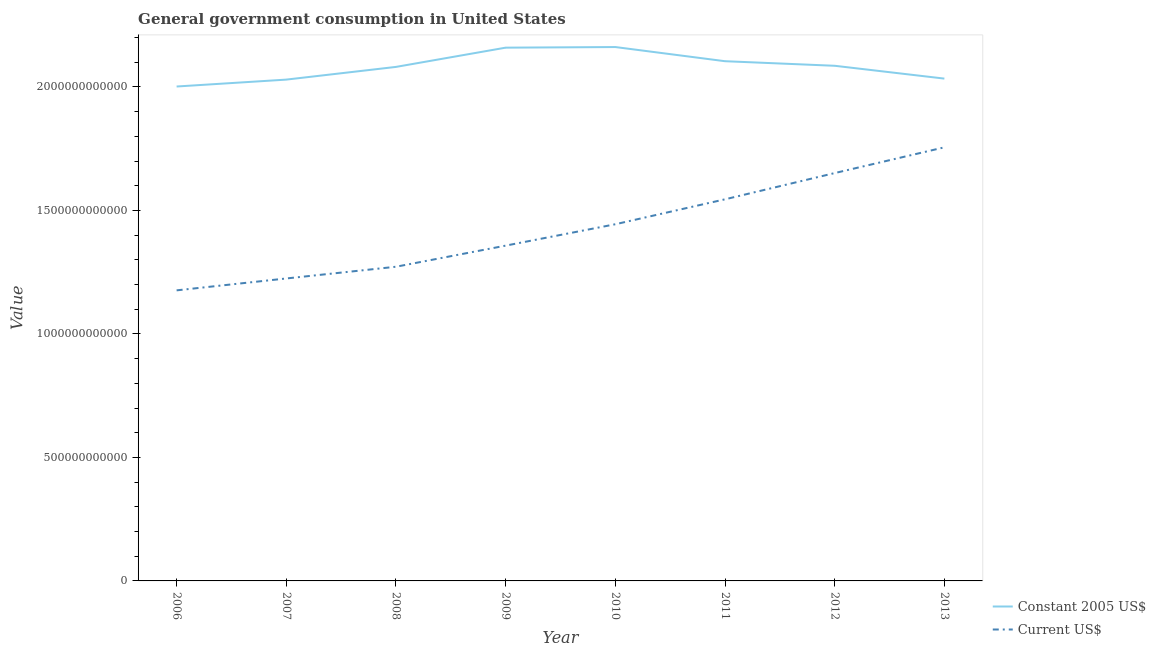What is the value consumed in constant 2005 us$ in 2007?
Make the answer very short. 2.03e+12. Across all years, what is the maximum value consumed in constant 2005 us$?
Your answer should be very brief. 2.16e+12. Across all years, what is the minimum value consumed in constant 2005 us$?
Give a very brief answer. 2.00e+12. In which year was the value consumed in current us$ maximum?
Provide a succinct answer. 2013. In which year was the value consumed in constant 2005 us$ minimum?
Ensure brevity in your answer.  2006. What is the total value consumed in constant 2005 us$ in the graph?
Offer a terse response. 1.67e+13. What is the difference between the value consumed in current us$ in 2008 and that in 2009?
Offer a very short reply. -8.55e+1. What is the difference between the value consumed in constant 2005 us$ in 2013 and the value consumed in current us$ in 2011?
Keep it short and to the point. 4.89e+11. What is the average value consumed in constant 2005 us$ per year?
Offer a terse response. 2.08e+12. In the year 2007, what is the difference between the value consumed in current us$ and value consumed in constant 2005 us$?
Provide a short and direct response. -8.05e+11. What is the ratio of the value consumed in current us$ in 2009 to that in 2010?
Your answer should be very brief. 0.94. Is the value consumed in constant 2005 us$ in 2009 less than that in 2010?
Offer a terse response. Yes. What is the difference between the highest and the second highest value consumed in current us$?
Keep it short and to the point. 1.04e+11. What is the difference between the highest and the lowest value consumed in current us$?
Your response must be concise. 5.79e+11. Does the value consumed in constant 2005 us$ monotonically increase over the years?
Your response must be concise. No. Is the value consumed in constant 2005 us$ strictly greater than the value consumed in current us$ over the years?
Offer a very short reply. Yes. How many lines are there?
Provide a short and direct response. 2. How many years are there in the graph?
Offer a terse response. 8. What is the difference between two consecutive major ticks on the Y-axis?
Offer a very short reply. 5.00e+11. Where does the legend appear in the graph?
Your answer should be very brief. Bottom right. How many legend labels are there?
Provide a succinct answer. 2. What is the title of the graph?
Offer a very short reply. General government consumption in United States. Does "Investments" appear as one of the legend labels in the graph?
Provide a short and direct response. No. What is the label or title of the X-axis?
Give a very brief answer. Year. What is the label or title of the Y-axis?
Provide a short and direct response. Value. What is the Value of Constant 2005 US$ in 2006?
Offer a very short reply. 2.00e+12. What is the Value of Current US$ in 2006?
Provide a succinct answer. 1.18e+12. What is the Value in Constant 2005 US$ in 2007?
Your answer should be very brief. 2.03e+12. What is the Value in Current US$ in 2007?
Give a very brief answer. 1.22e+12. What is the Value of Constant 2005 US$ in 2008?
Ensure brevity in your answer.  2.08e+12. What is the Value in Current US$ in 2008?
Provide a succinct answer. 1.27e+12. What is the Value of Constant 2005 US$ in 2009?
Your answer should be compact. 2.16e+12. What is the Value of Current US$ in 2009?
Your response must be concise. 1.36e+12. What is the Value of Constant 2005 US$ in 2010?
Your answer should be very brief. 2.16e+12. What is the Value in Current US$ in 2010?
Your response must be concise. 1.44e+12. What is the Value in Constant 2005 US$ in 2011?
Offer a very short reply. 2.10e+12. What is the Value of Current US$ in 2011?
Provide a short and direct response. 1.55e+12. What is the Value of Constant 2005 US$ in 2012?
Your response must be concise. 2.09e+12. What is the Value in Current US$ in 2012?
Make the answer very short. 1.65e+12. What is the Value of Constant 2005 US$ in 2013?
Ensure brevity in your answer.  2.03e+12. What is the Value in Current US$ in 2013?
Keep it short and to the point. 1.76e+12. Across all years, what is the maximum Value of Constant 2005 US$?
Provide a succinct answer. 2.16e+12. Across all years, what is the maximum Value of Current US$?
Your answer should be compact. 1.76e+12. Across all years, what is the minimum Value in Constant 2005 US$?
Give a very brief answer. 2.00e+12. Across all years, what is the minimum Value of Current US$?
Offer a very short reply. 1.18e+12. What is the total Value of Constant 2005 US$ in the graph?
Give a very brief answer. 1.67e+13. What is the total Value of Current US$ in the graph?
Your answer should be compact. 1.14e+13. What is the difference between the Value of Constant 2005 US$ in 2006 and that in 2007?
Offer a very short reply. -2.79e+1. What is the difference between the Value in Current US$ in 2006 and that in 2007?
Your answer should be compact. -4.81e+1. What is the difference between the Value of Constant 2005 US$ in 2006 and that in 2008?
Provide a succinct answer. -7.94e+1. What is the difference between the Value of Current US$ in 2006 and that in 2008?
Your answer should be very brief. -9.56e+1. What is the difference between the Value in Constant 2005 US$ in 2006 and that in 2009?
Offer a terse response. -1.57e+11. What is the difference between the Value of Current US$ in 2006 and that in 2009?
Your response must be concise. -1.81e+11. What is the difference between the Value in Constant 2005 US$ in 2006 and that in 2010?
Make the answer very short. -1.60e+11. What is the difference between the Value in Current US$ in 2006 and that in 2010?
Offer a terse response. -2.68e+11. What is the difference between the Value in Constant 2005 US$ in 2006 and that in 2011?
Your answer should be very brief. -1.02e+11. What is the difference between the Value in Current US$ in 2006 and that in 2011?
Your answer should be very brief. -3.69e+11. What is the difference between the Value in Constant 2005 US$ in 2006 and that in 2012?
Keep it short and to the point. -8.39e+1. What is the difference between the Value in Current US$ in 2006 and that in 2012?
Ensure brevity in your answer.  -4.75e+11. What is the difference between the Value in Constant 2005 US$ in 2006 and that in 2013?
Make the answer very short. -3.20e+1. What is the difference between the Value of Current US$ in 2006 and that in 2013?
Give a very brief answer. -5.79e+11. What is the difference between the Value of Constant 2005 US$ in 2007 and that in 2008?
Give a very brief answer. -5.14e+1. What is the difference between the Value in Current US$ in 2007 and that in 2008?
Your answer should be compact. -4.75e+1. What is the difference between the Value in Constant 2005 US$ in 2007 and that in 2009?
Your answer should be compact. -1.29e+11. What is the difference between the Value of Current US$ in 2007 and that in 2009?
Provide a short and direct response. -1.33e+11. What is the difference between the Value in Constant 2005 US$ in 2007 and that in 2010?
Provide a succinct answer. -1.32e+11. What is the difference between the Value in Current US$ in 2007 and that in 2010?
Your answer should be compact. -2.20e+11. What is the difference between the Value in Constant 2005 US$ in 2007 and that in 2011?
Keep it short and to the point. -7.45e+1. What is the difference between the Value in Current US$ in 2007 and that in 2011?
Your answer should be compact. -3.21e+11. What is the difference between the Value in Constant 2005 US$ in 2007 and that in 2012?
Your answer should be compact. -5.60e+1. What is the difference between the Value in Current US$ in 2007 and that in 2012?
Your response must be concise. -4.27e+11. What is the difference between the Value of Constant 2005 US$ in 2007 and that in 2013?
Your response must be concise. -4.06e+09. What is the difference between the Value in Current US$ in 2007 and that in 2013?
Make the answer very short. -5.31e+11. What is the difference between the Value of Constant 2005 US$ in 2008 and that in 2009?
Provide a short and direct response. -7.80e+1. What is the difference between the Value in Current US$ in 2008 and that in 2009?
Offer a very short reply. -8.55e+1. What is the difference between the Value of Constant 2005 US$ in 2008 and that in 2010?
Offer a terse response. -8.04e+1. What is the difference between the Value in Current US$ in 2008 and that in 2010?
Make the answer very short. -1.72e+11. What is the difference between the Value of Constant 2005 US$ in 2008 and that in 2011?
Offer a very short reply. -2.31e+1. What is the difference between the Value of Current US$ in 2008 and that in 2011?
Ensure brevity in your answer.  -2.73e+11. What is the difference between the Value of Constant 2005 US$ in 2008 and that in 2012?
Keep it short and to the point. -4.58e+09. What is the difference between the Value in Current US$ in 2008 and that in 2012?
Give a very brief answer. -3.79e+11. What is the difference between the Value of Constant 2005 US$ in 2008 and that in 2013?
Your response must be concise. 4.74e+1. What is the difference between the Value in Current US$ in 2008 and that in 2013?
Your response must be concise. -4.83e+11. What is the difference between the Value in Constant 2005 US$ in 2009 and that in 2010?
Make the answer very short. -2.48e+09. What is the difference between the Value of Current US$ in 2009 and that in 2010?
Your answer should be compact. -8.66e+1. What is the difference between the Value of Constant 2005 US$ in 2009 and that in 2011?
Your response must be concise. 5.49e+1. What is the difference between the Value of Current US$ in 2009 and that in 2011?
Provide a succinct answer. -1.88e+11. What is the difference between the Value of Constant 2005 US$ in 2009 and that in 2012?
Provide a short and direct response. 7.34e+1. What is the difference between the Value in Current US$ in 2009 and that in 2012?
Your answer should be compact. -2.94e+11. What is the difference between the Value of Constant 2005 US$ in 2009 and that in 2013?
Your answer should be compact. 1.25e+11. What is the difference between the Value in Current US$ in 2009 and that in 2013?
Offer a terse response. -3.98e+11. What is the difference between the Value of Constant 2005 US$ in 2010 and that in 2011?
Your answer should be very brief. 5.74e+1. What is the difference between the Value of Current US$ in 2010 and that in 2011?
Give a very brief answer. -1.01e+11. What is the difference between the Value in Constant 2005 US$ in 2010 and that in 2012?
Give a very brief answer. 7.59e+1. What is the difference between the Value in Current US$ in 2010 and that in 2012?
Your response must be concise. -2.07e+11. What is the difference between the Value in Constant 2005 US$ in 2010 and that in 2013?
Make the answer very short. 1.28e+11. What is the difference between the Value of Current US$ in 2010 and that in 2013?
Make the answer very short. -3.11e+11. What is the difference between the Value of Constant 2005 US$ in 2011 and that in 2012?
Offer a very short reply. 1.85e+1. What is the difference between the Value of Current US$ in 2011 and that in 2012?
Make the answer very short. -1.06e+11. What is the difference between the Value in Constant 2005 US$ in 2011 and that in 2013?
Make the answer very short. 7.04e+1. What is the difference between the Value of Current US$ in 2011 and that in 2013?
Keep it short and to the point. -2.10e+11. What is the difference between the Value in Constant 2005 US$ in 2012 and that in 2013?
Offer a very short reply. 5.19e+1. What is the difference between the Value of Current US$ in 2012 and that in 2013?
Provide a short and direct response. -1.04e+11. What is the difference between the Value of Constant 2005 US$ in 2006 and the Value of Current US$ in 2007?
Keep it short and to the point. 7.77e+11. What is the difference between the Value of Constant 2005 US$ in 2006 and the Value of Current US$ in 2008?
Provide a short and direct response. 7.30e+11. What is the difference between the Value in Constant 2005 US$ in 2006 and the Value in Current US$ in 2009?
Your answer should be very brief. 6.44e+11. What is the difference between the Value in Constant 2005 US$ in 2006 and the Value in Current US$ in 2010?
Your response must be concise. 5.58e+11. What is the difference between the Value of Constant 2005 US$ in 2006 and the Value of Current US$ in 2011?
Give a very brief answer. 4.57e+11. What is the difference between the Value in Constant 2005 US$ in 2006 and the Value in Current US$ in 2012?
Your answer should be very brief. 3.50e+11. What is the difference between the Value of Constant 2005 US$ in 2006 and the Value of Current US$ in 2013?
Keep it short and to the point. 2.46e+11. What is the difference between the Value in Constant 2005 US$ in 2007 and the Value in Current US$ in 2008?
Offer a terse response. 7.58e+11. What is the difference between the Value of Constant 2005 US$ in 2007 and the Value of Current US$ in 2009?
Offer a very short reply. 6.72e+11. What is the difference between the Value in Constant 2005 US$ in 2007 and the Value in Current US$ in 2010?
Keep it short and to the point. 5.86e+11. What is the difference between the Value of Constant 2005 US$ in 2007 and the Value of Current US$ in 2011?
Offer a very short reply. 4.85e+11. What is the difference between the Value of Constant 2005 US$ in 2007 and the Value of Current US$ in 2012?
Keep it short and to the point. 3.78e+11. What is the difference between the Value in Constant 2005 US$ in 2007 and the Value in Current US$ in 2013?
Provide a succinct answer. 2.74e+11. What is the difference between the Value in Constant 2005 US$ in 2008 and the Value in Current US$ in 2009?
Your response must be concise. 7.24e+11. What is the difference between the Value of Constant 2005 US$ in 2008 and the Value of Current US$ in 2010?
Keep it short and to the point. 6.37e+11. What is the difference between the Value of Constant 2005 US$ in 2008 and the Value of Current US$ in 2011?
Ensure brevity in your answer.  5.36e+11. What is the difference between the Value in Constant 2005 US$ in 2008 and the Value in Current US$ in 2012?
Offer a terse response. 4.30e+11. What is the difference between the Value of Constant 2005 US$ in 2008 and the Value of Current US$ in 2013?
Offer a terse response. 3.26e+11. What is the difference between the Value in Constant 2005 US$ in 2009 and the Value in Current US$ in 2010?
Your response must be concise. 7.15e+11. What is the difference between the Value in Constant 2005 US$ in 2009 and the Value in Current US$ in 2011?
Make the answer very short. 6.14e+11. What is the difference between the Value in Constant 2005 US$ in 2009 and the Value in Current US$ in 2012?
Ensure brevity in your answer.  5.08e+11. What is the difference between the Value of Constant 2005 US$ in 2009 and the Value of Current US$ in 2013?
Keep it short and to the point. 4.04e+11. What is the difference between the Value of Constant 2005 US$ in 2010 and the Value of Current US$ in 2011?
Provide a succinct answer. 6.17e+11. What is the difference between the Value of Constant 2005 US$ in 2010 and the Value of Current US$ in 2012?
Offer a very short reply. 5.10e+11. What is the difference between the Value in Constant 2005 US$ in 2010 and the Value in Current US$ in 2013?
Your answer should be very brief. 4.06e+11. What is the difference between the Value of Constant 2005 US$ in 2011 and the Value of Current US$ in 2012?
Your answer should be very brief. 4.53e+11. What is the difference between the Value of Constant 2005 US$ in 2011 and the Value of Current US$ in 2013?
Your answer should be compact. 3.49e+11. What is the difference between the Value of Constant 2005 US$ in 2012 and the Value of Current US$ in 2013?
Offer a very short reply. 3.30e+11. What is the average Value in Constant 2005 US$ per year?
Provide a short and direct response. 2.08e+12. What is the average Value of Current US$ per year?
Offer a terse response. 1.43e+12. In the year 2006, what is the difference between the Value in Constant 2005 US$ and Value in Current US$?
Make the answer very short. 8.25e+11. In the year 2007, what is the difference between the Value in Constant 2005 US$ and Value in Current US$?
Provide a succinct answer. 8.05e+11. In the year 2008, what is the difference between the Value of Constant 2005 US$ and Value of Current US$?
Provide a short and direct response. 8.09e+11. In the year 2009, what is the difference between the Value of Constant 2005 US$ and Value of Current US$?
Provide a succinct answer. 8.02e+11. In the year 2010, what is the difference between the Value in Constant 2005 US$ and Value in Current US$?
Give a very brief answer. 7.17e+11. In the year 2011, what is the difference between the Value in Constant 2005 US$ and Value in Current US$?
Ensure brevity in your answer.  5.59e+11. In the year 2012, what is the difference between the Value of Constant 2005 US$ and Value of Current US$?
Give a very brief answer. 4.34e+11. In the year 2013, what is the difference between the Value of Constant 2005 US$ and Value of Current US$?
Make the answer very short. 2.78e+11. What is the ratio of the Value of Constant 2005 US$ in 2006 to that in 2007?
Give a very brief answer. 0.99. What is the ratio of the Value of Current US$ in 2006 to that in 2007?
Make the answer very short. 0.96. What is the ratio of the Value of Constant 2005 US$ in 2006 to that in 2008?
Offer a very short reply. 0.96. What is the ratio of the Value of Current US$ in 2006 to that in 2008?
Keep it short and to the point. 0.92. What is the ratio of the Value in Constant 2005 US$ in 2006 to that in 2009?
Your answer should be compact. 0.93. What is the ratio of the Value of Current US$ in 2006 to that in 2009?
Offer a very short reply. 0.87. What is the ratio of the Value of Constant 2005 US$ in 2006 to that in 2010?
Keep it short and to the point. 0.93. What is the ratio of the Value in Current US$ in 2006 to that in 2010?
Offer a terse response. 0.81. What is the ratio of the Value of Constant 2005 US$ in 2006 to that in 2011?
Ensure brevity in your answer.  0.95. What is the ratio of the Value in Current US$ in 2006 to that in 2011?
Make the answer very short. 0.76. What is the ratio of the Value of Constant 2005 US$ in 2006 to that in 2012?
Give a very brief answer. 0.96. What is the ratio of the Value in Current US$ in 2006 to that in 2012?
Provide a succinct answer. 0.71. What is the ratio of the Value in Constant 2005 US$ in 2006 to that in 2013?
Provide a succinct answer. 0.98. What is the ratio of the Value of Current US$ in 2006 to that in 2013?
Offer a very short reply. 0.67. What is the ratio of the Value of Constant 2005 US$ in 2007 to that in 2008?
Your answer should be compact. 0.98. What is the ratio of the Value of Current US$ in 2007 to that in 2008?
Make the answer very short. 0.96. What is the ratio of the Value in Constant 2005 US$ in 2007 to that in 2009?
Offer a terse response. 0.94. What is the ratio of the Value in Current US$ in 2007 to that in 2009?
Ensure brevity in your answer.  0.9. What is the ratio of the Value in Constant 2005 US$ in 2007 to that in 2010?
Ensure brevity in your answer.  0.94. What is the ratio of the Value in Current US$ in 2007 to that in 2010?
Keep it short and to the point. 0.85. What is the ratio of the Value of Constant 2005 US$ in 2007 to that in 2011?
Make the answer very short. 0.96. What is the ratio of the Value of Current US$ in 2007 to that in 2011?
Ensure brevity in your answer.  0.79. What is the ratio of the Value of Constant 2005 US$ in 2007 to that in 2012?
Offer a terse response. 0.97. What is the ratio of the Value of Current US$ in 2007 to that in 2012?
Your response must be concise. 0.74. What is the ratio of the Value of Constant 2005 US$ in 2007 to that in 2013?
Keep it short and to the point. 1. What is the ratio of the Value of Current US$ in 2007 to that in 2013?
Your answer should be compact. 0.7. What is the ratio of the Value in Constant 2005 US$ in 2008 to that in 2009?
Give a very brief answer. 0.96. What is the ratio of the Value of Current US$ in 2008 to that in 2009?
Offer a terse response. 0.94. What is the ratio of the Value of Constant 2005 US$ in 2008 to that in 2010?
Make the answer very short. 0.96. What is the ratio of the Value in Current US$ in 2008 to that in 2010?
Offer a terse response. 0.88. What is the ratio of the Value of Current US$ in 2008 to that in 2011?
Your answer should be compact. 0.82. What is the ratio of the Value in Constant 2005 US$ in 2008 to that in 2012?
Offer a very short reply. 1. What is the ratio of the Value in Current US$ in 2008 to that in 2012?
Provide a succinct answer. 0.77. What is the ratio of the Value in Constant 2005 US$ in 2008 to that in 2013?
Your answer should be compact. 1.02. What is the ratio of the Value of Current US$ in 2008 to that in 2013?
Offer a terse response. 0.72. What is the ratio of the Value of Constant 2005 US$ in 2009 to that in 2011?
Provide a succinct answer. 1.03. What is the ratio of the Value in Current US$ in 2009 to that in 2011?
Provide a short and direct response. 0.88. What is the ratio of the Value of Constant 2005 US$ in 2009 to that in 2012?
Keep it short and to the point. 1.04. What is the ratio of the Value of Current US$ in 2009 to that in 2012?
Ensure brevity in your answer.  0.82. What is the ratio of the Value of Constant 2005 US$ in 2009 to that in 2013?
Provide a short and direct response. 1.06. What is the ratio of the Value of Current US$ in 2009 to that in 2013?
Your answer should be compact. 0.77. What is the ratio of the Value in Constant 2005 US$ in 2010 to that in 2011?
Provide a short and direct response. 1.03. What is the ratio of the Value of Current US$ in 2010 to that in 2011?
Provide a short and direct response. 0.93. What is the ratio of the Value of Constant 2005 US$ in 2010 to that in 2012?
Your response must be concise. 1.04. What is the ratio of the Value of Current US$ in 2010 to that in 2012?
Offer a terse response. 0.87. What is the ratio of the Value in Constant 2005 US$ in 2010 to that in 2013?
Offer a very short reply. 1.06. What is the ratio of the Value of Current US$ in 2010 to that in 2013?
Your answer should be compact. 0.82. What is the ratio of the Value in Constant 2005 US$ in 2011 to that in 2012?
Ensure brevity in your answer.  1.01. What is the ratio of the Value in Current US$ in 2011 to that in 2012?
Your response must be concise. 0.94. What is the ratio of the Value in Constant 2005 US$ in 2011 to that in 2013?
Offer a terse response. 1.03. What is the ratio of the Value of Current US$ in 2011 to that in 2013?
Your answer should be compact. 0.88. What is the ratio of the Value of Constant 2005 US$ in 2012 to that in 2013?
Keep it short and to the point. 1.03. What is the ratio of the Value of Current US$ in 2012 to that in 2013?
Your answer should be compact. 0.94. What is the difference between the highest and the second highest Value in Constant 2005 US$?
Your response must be concise. 2.48e+09. What is the difference between the highest and the second highest Value in Current US$?
Ensure brevity in your answer.  1.04e+11. What is the difference between the highest and the lowest Value in Constant 2005 US$?
Offer a very short reply. 1.60e+11. What is the difference between the highest and the lowest Value in Current US$?
Keep it short and to the point. 5.79e+11. 